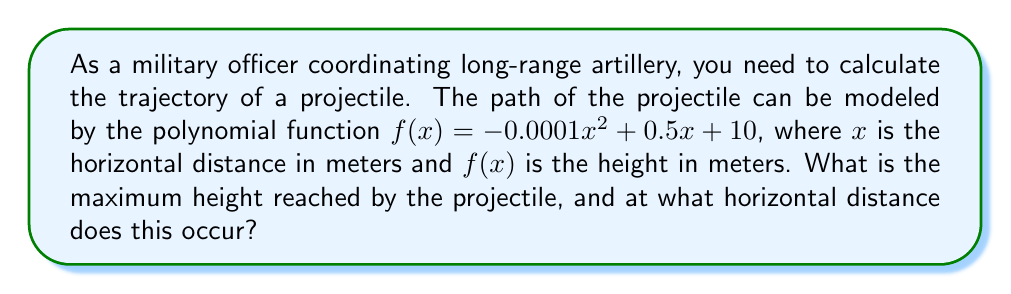Give your solution to this math problem. To find the maximum height of the projectile and its corresponding horizontal distance, we need to follow these steps:

1) The polynomial function given is $f(x) = -0.0001x^2 + 0.5x + 10$

2) To find the maximum point, we need to find where the derivative of this function equals zero.

3) The derivative of $f(x)$ is:
   $f'(x) = -0.0002x + 0.5$

4) Set $f'(x) = 0$ and solve for $x$:
   $-0.0002x + 0.5 = 0$
   $-0.0002x = -0.5$
   $x = \frac{-0.5}{-0.0002} = 2500$

5) The horizontal distance at which the maximum height occurs is 2500 meters.

6) To find the maximum height, we substitute $x = 2500$ into the original function:

   $f(2500) = -0.0001(2500)^2 + 0.5(2500) + 10$
            $= -0.0001(6,250,000) + 1250 + 10$
            $= -625 + 1250 + 10$
            $= 635$

Therefore, the maximum height reached is 635 meters.
Answer: Maximum height: 635 meters; Horizontal distance: 2500 meters 